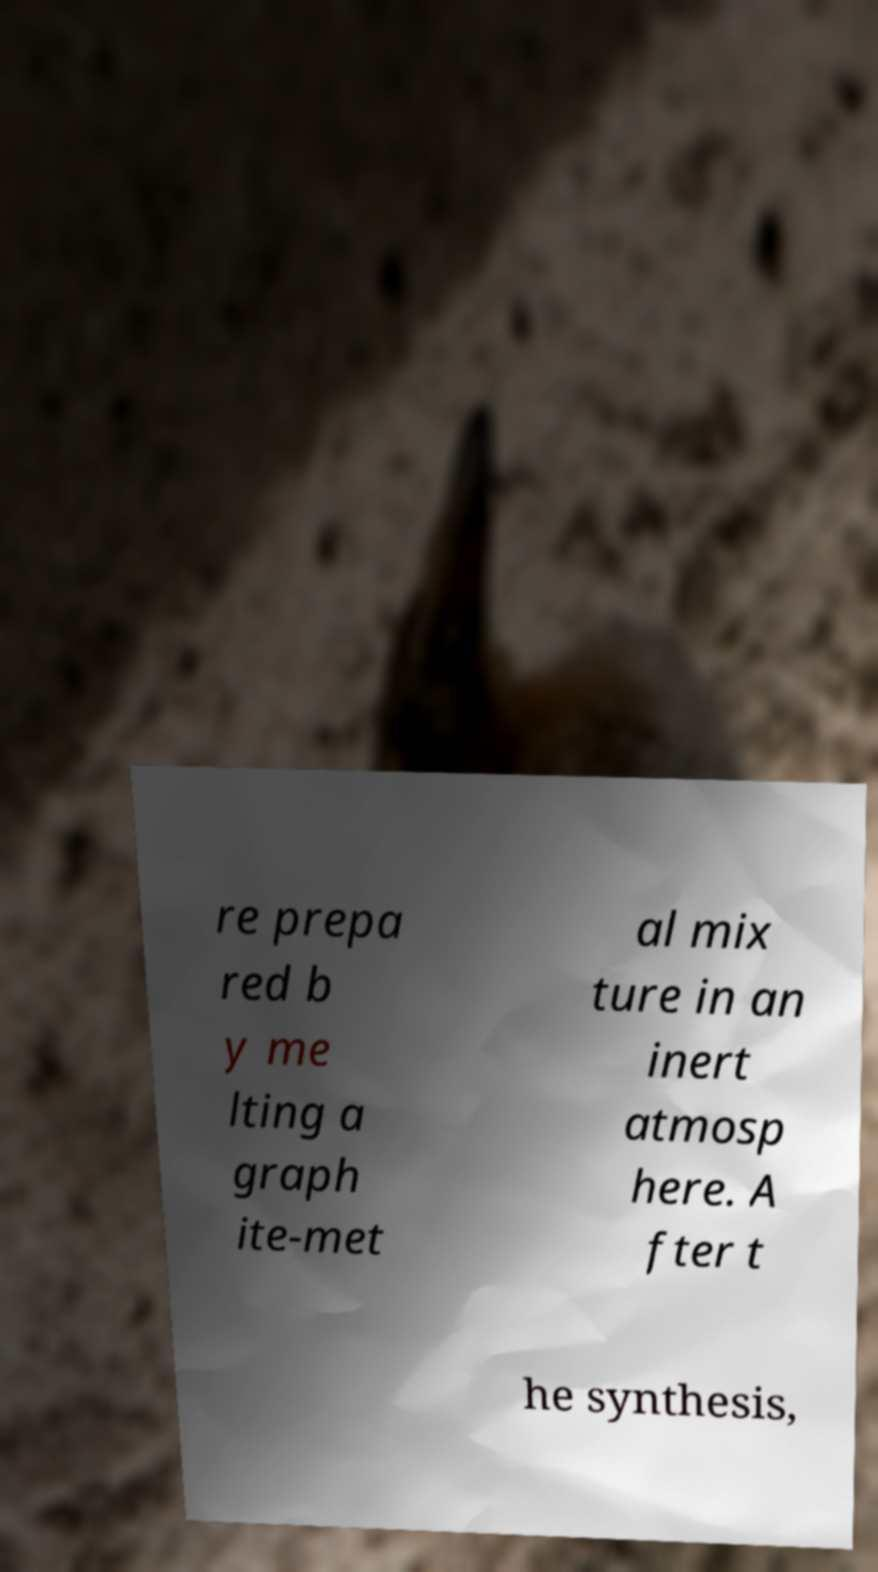Could you assist in decoding the text presented in this image and type it out clearly? re prepa red b y me lting a graph ite-met al mix ture in an inert atmosp here. A fter t he synthesis, 